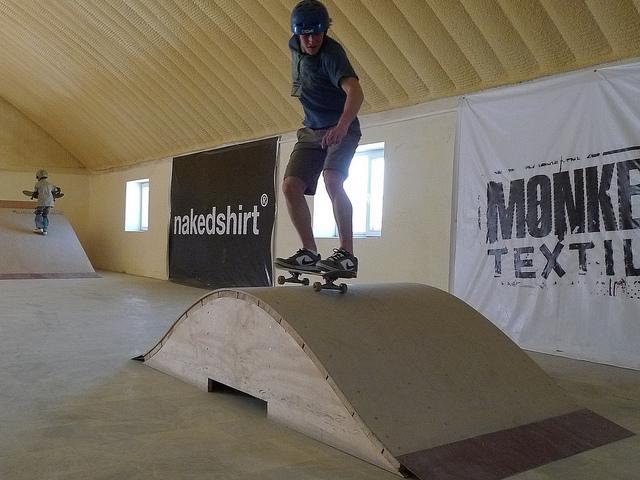Is the skatepark outdoors?
Concise answer only. No. How many skaters are there?
Write a very short answer. 2. What two colors are in a pattern on the platforms and ramps?
Answer briefly. Brown and tan. What does the sign say?
Quick response, please. Nakedshirt. 